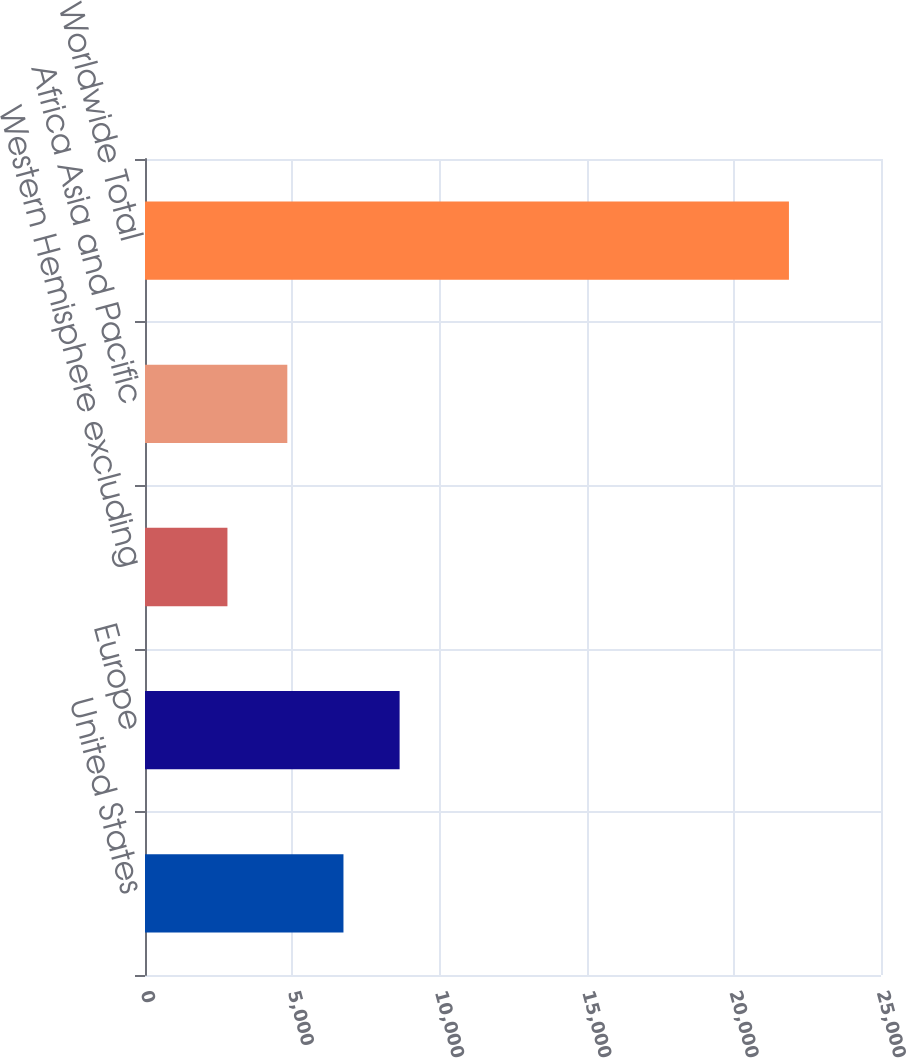Convert chart to OTSL. <chart><loc_0><loc_0><loc_500><loc_500><bar_chart><fcel>United States<fcel>Europe<fcel>Western Hemisphere excluding<fcel>Africa Asia and Pacific<fcel>Worldwide Total<nl><fcel>6741.3<fcel>8648.6<fcel>2800<fcel>4834<fcel>21873<nl></chart> 